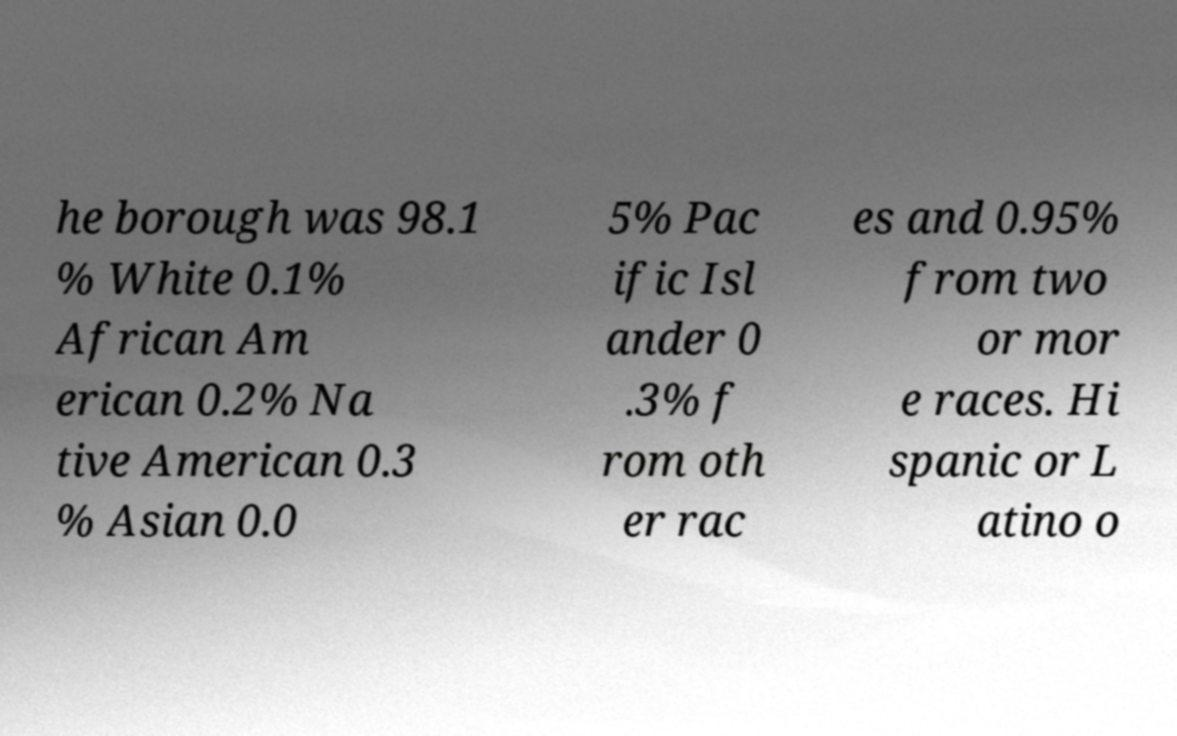Please read and relay the text visible in this image. What does it say? he borough was 98.1 % White 0.1% African Am erican 0.2% Na tive American 0.3 % Asian 0.0 5% Pac ific Isl ander 0 .3% f rom oth er rac es and 0.95% from two or mor e races. Hi spanic or L atino o 